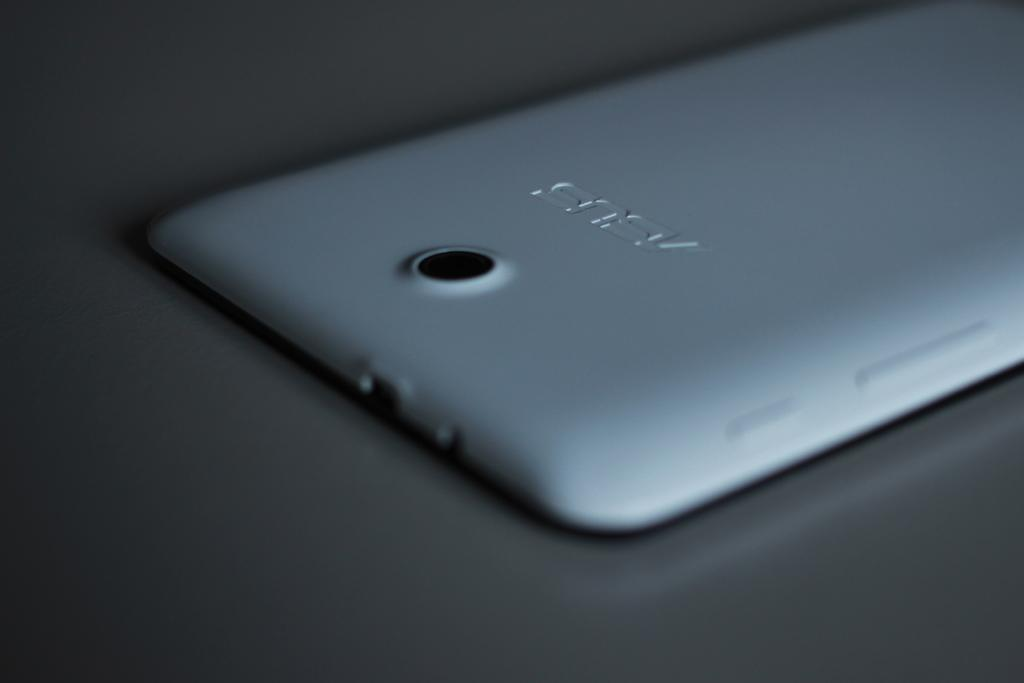Provide a one-sentence caption for the provided image. the back of an Asus cell phone with camera. 